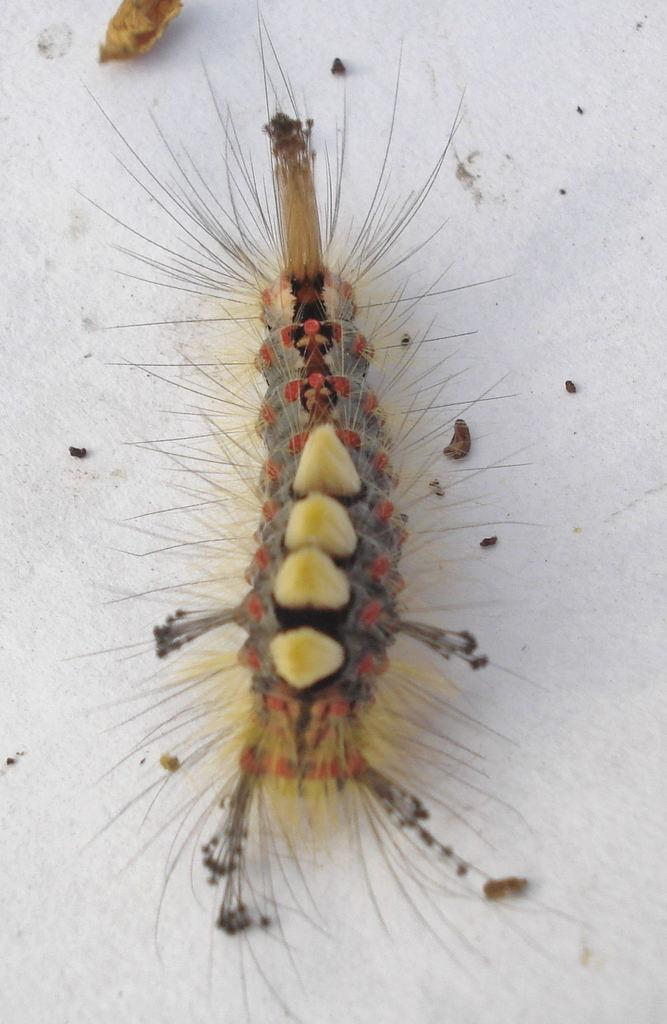What is the main subject of the picture? The main subject of the picture is an insect. What is the color of the surface where the insect is located? The insect is on a white color surface. What else can be seen in the picture besides the insect? There are dust particles visible in the picture. What type of veil is the insect wearing in the picture? There is no veil present on the insect in the image. What are the insect's hobbies, as depicted in the picture? The picture does not provide information about the insect's hobbies. 